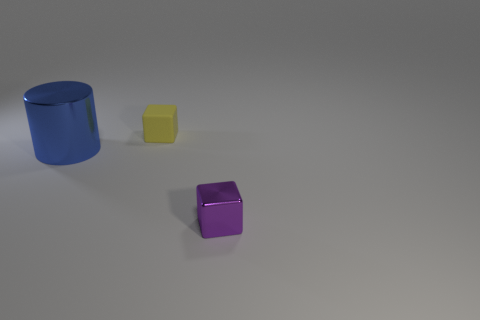Are any cylinders visible?
Ensure brevity in your answer.  Yes. What is the size of the other purple thing that is the same material as the large thing?
Offer a terse response. Small. Is there a metal cylinder that has the same color as the small matte object?
Your answer should be compact. No. Is the color of the shiny thing to the right of the tiny yellow rubber thing the same as the object behind the big thing?
Offer a terse response. No. Is there a tiny brown sphere that has the same material as the cylinder?
Ensure brevity in your answer.  No. What is the color of the tiny metallic block?
Your answer should be very brief. Purple. There is a cube that is behind the thing right of the block that is behind the big cylinder; what size is it?
Your answer should be compact. Small. How many other objects are the same shape as the big object?
Give a very brief answer. 0. The object that is both in front of the yellow block and right of the large metal cylinder is what color?
Provide a succinct answer. Purple. Is there anything else that is the same size as the purple thing?
Give a very brief answer. Yes. 